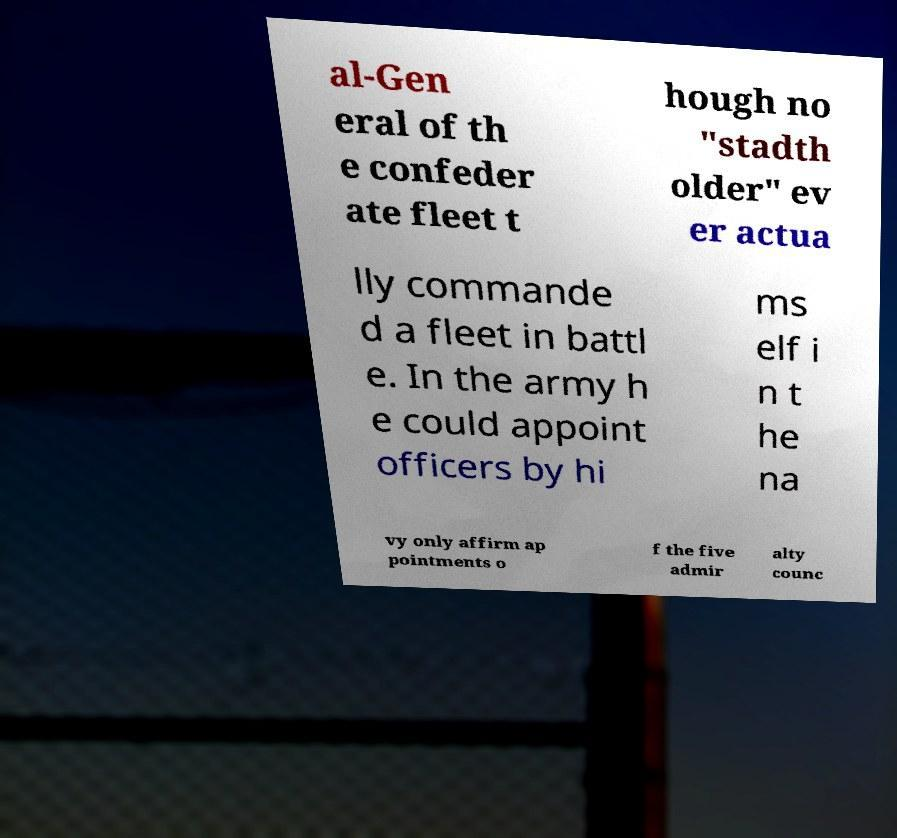For documentation purposes, I need the text within this image transcribed. Could you provide that? al-Gen eral of th e confeder ate fleet t hough no "stadth older" ev er actua lly commande d a fleet in battl e. In the army h e could appoint officers by hi ms elf i n t he na vy only affirm ap pointments o f the five admir alty counc 